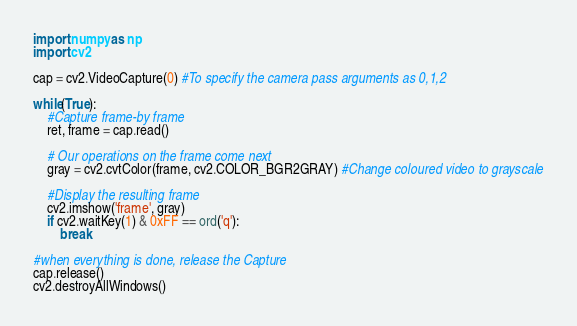Convert code to text. <code><loc_0><loc_0><loc_500><loc_500><_Python_>import numpy as np
import cv2

cap = cv2.VideoCapture(0) #To specify the camera pass arguments as 0,1,2

while(True):
    #Capture frame-by frame
    ret, frame = cap.read()

    # Our operations on the frame come next
    gray = cv2.cvtColor(frame, cv2.COLOR_BGR2GRAY) #Change coloured video to grayscale

    #Display the resulting frame
    cv2.imshow('frame', gray)
    if cv2.waitKey(1) & 0xFF == ord('q'):
        break

#when everything is done, release the Capture
cap.release()
cv2.destroyAllWindows()
</code> 